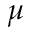Convert formula to latex. <formula><loc_0><loc_0><loc_500><loc_500>\mu</formula> 